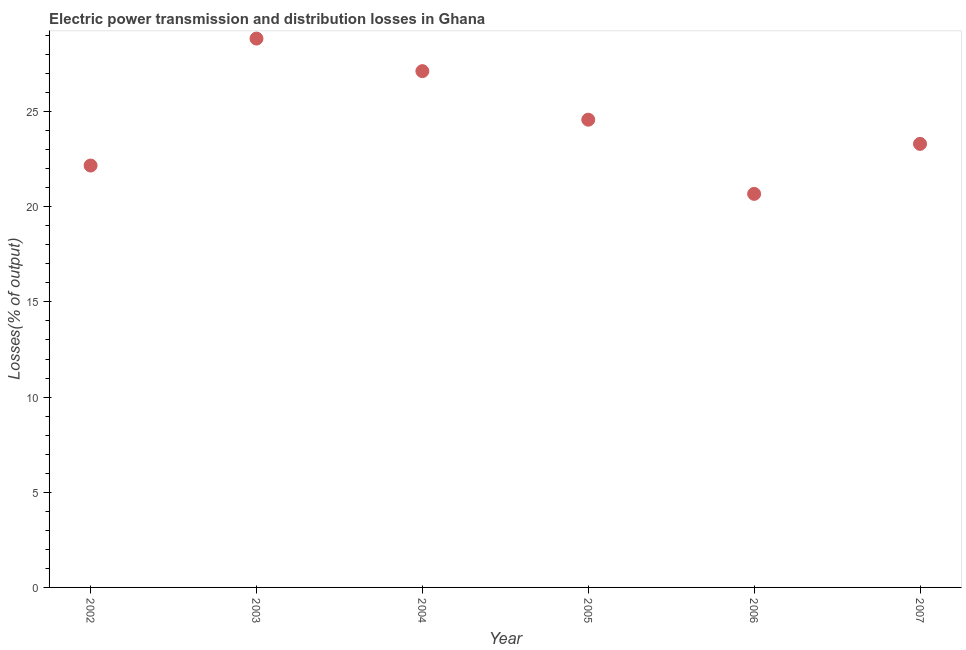What is the electric power transmission and distribution losses in 2006?
Give a very brief answer. 20.68. Across all years, what is the maximum electric power transmission and distribution losses?
Your answer should be very brief. 28.83. Across all years, what is the minimum electric power transmission and distribution losses?
Your answer should be very brief. 20.68. In which year was the electric power transmission and distribution losses maximum?
Offer a terse response. 2003. In which year was the electric power transmission and distribution losses minimum?
Give a very brief answer. 2006. What is the sum of the electric power transmission and distribution losses?
Offer a very short reply. 146.67. What is the difference between the electric power transmission and distribution losses in 2002 and 2004?
Provide a succinct answer. -4.96. What is the average electric power transmission and distribution losses per year?
Your answer should be very brief. 24.45. What is the median electric power transmission and distribution losses?
Your answer should be compact. 23.94. What is the ratio of the electric power transmission and distribution losses in 2004 to that in 2005?
Your answer should be compact. 1.1. Is the electric power transmission and distribution losses in 2002 less than that in 2005?
Offer a terse response. Yes. What is the difference between the highest and the second highest electric power transmission and distribution losses?
Provide a succinct answer. 1.71. Is the sum of the electric power transmission and distribution losses in 2002 and 2005 greater than the maximum electric power transmission and distribution losses across all years?
Offer a terse response. Yes. What is the difference between the highest and the lowest electric power transmission and distribution losses?
Your response must be concise. 8.16. What is the title of the graph?
Your answer should be very brief. Electric power transmission and distribution losses in Ghana. What is the label or title of the Y-axis?
Your answer should be very brief. Losses(% of output). What is the Losses(% of output) in 2002?
Keep it short and to the point. 22.16. What is the Losses(% of output) in 2003?
Offer a very short reply. 28.83. What is the Losses(% of output) in 2004?
Keep it short and to the point. 27.12. What is the Losses(% of output) in 2005?
Your answer should be compact. 24.57. What is the Losses(% of output) in 2006?
Offer a terse response. 20.68. What is the Losses(% of output) in 2007?
Ensure brevity in your answer.  23.3. What is the difference between the Losses(% of output) in 2002 and 2003?
Offer a terse response. -6.67. What is the difference between the Losses(% of output) in 2002 and 2004?
Offer a very short reply. -4.96. What is the difference between the Losses(% of output) in 2002 and 2005?
Your answer should be compact. -2.41. What is the difference between the Losses(% of output) in 2002 and 2006?
Give a very brief answer. 1.49. What is the difference between the Losses(% of output) in 2002 and 2007?
Provide a succinct answer. -1.14. What is the difference between the Losses(% of output) in 2003 and 2004?
Keep it short and to the point. 1.71. What is the difference between the Losses(% of output) in 2003 and 2005?
Provide a succinct answer. 4.26. What is the difference between the Losses(% of output) in 2003 and 2006?
Provide a short and direct response. 8.16. What is the difference between the Losses(% of output) in 2003 and 2007?
Offer a very short reply. 5.53. What is the difference between the Losses(% of output) in 2004 and 2005?
Your answer should be very brief. 2.55. What is the difference between the Losses(% of output) in 2004 and 2006?
Your answer should be compact. 6.45. What is the difference between the Losses(% of output) in 2004 and 2007?
Provide a short and direct response. 3.82. What is the difference between the Losses(% of output) in 2005 and 2006?
Your response must be concise. 3.9. What is the difference between the Losses(% of output) in 2005 and 2007?
Provide a succinct answer. 1.27. What is the difference between the Losses(% of output) in 2006 and 2007?
Provide a succinct answer. -2.63. What is the ratio of the Losses(% of output) in 2002 to that in 2003?
Keep it short and to the point. 0.77. What is the ratio of the Losses(% of output) in 2002 to that in 2004?
Provide a short and direct response. 0.82. What is the ratio of the Losses(% of output) in 2002 to that in 2005?
Ensure brevity in your answer.  0.9. What is the ratio of the Losses(% of output) in 2002 to that in 2006?
Provide a short and direct response. 1.07. What is the ratio of the Losses(% of output) in 2002 to that in 2007?
Provide a succinct answer. 0.95. What is the ratio of the Losses(% of output) in 2003 to that in 2004?
Your answer should be very brief. 1.06. What is the ratio of the Losses(% of output) in 2003 to that in 2005?
Your answer should be very brief. 1.17. What is the ratio of the Losses(% of output) in 2003 to that in 2006?
Offer a very short reply. 1.4. What is the ratio of the Losses(% of output) in 2003 to that in 2007?
Ensure brevity in your answer.  1.24. What is the ratio of the Losses(% of output) in 2004 to that in 2005?
Make the answer very short. 1.1. What is the ratio of the Losses(% of output) in 2004 to that in 2006?
Give a very brief answer. 1.31. What is the ratio of the Losses(% of output) in 2004 to that in 2007?
Your answer should be compact. 1.16. What is the ratio of the Losses(% of output) in 2005 to that in 2006?
Your answer should be compact. 1.19. What is the ratio of the Losses(% of output) in 2005 to that in 2007?
Provide a short and direct response. 1.05. What is the ratio of the Losses(% of output) in 2006 to that in 2007?
Keep it short and to the point. 0.89. 